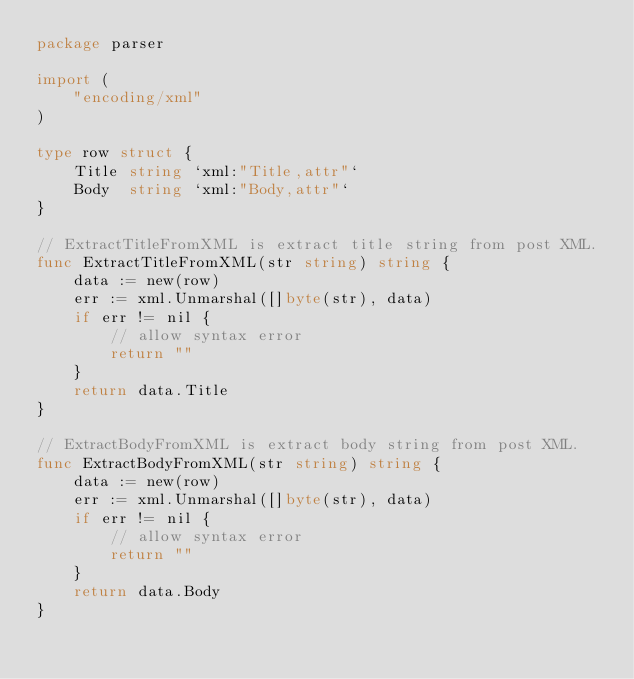Convert code to text. <code><loc_0><loc_0><loc_500><loc_500><_Go_>package parser

import (
	"encoding/xml"
)

type row struct {
	Title string `xml:"Title,attr"`
	Body  string `xml:"Body,attr"`
}

// ExtractTitleFromXML is extract title string from post XML.
func ExtractTitleFromXML(str string) string {
	data := new(row)
	err := xml.Unmarshal([]byte(str), data)
	if err != nil {
		// allow syntax error
		return ""
	}
	return data.Title
}

// ExtractBodyFromXML is extract body string from post XML.
func ExtractBodyFromXML(str string) string {
	data := new(row)
	err := xml.Unmarshal([]byte(str), data)
	if err != nil {
		// allow syntax error
		return ""
	}
	return data.Body
}
</code> 